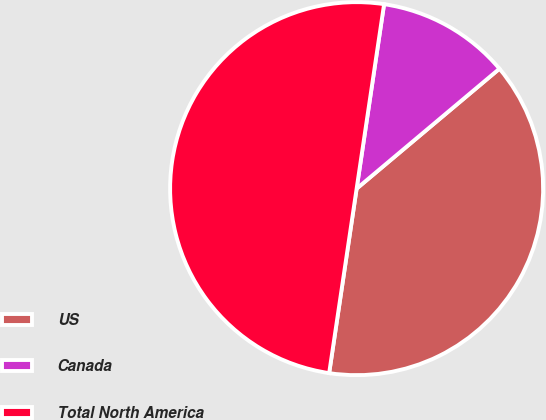Convert chart. <chart><loc_0><loc_0><loc_500><loc_500><pie_chart><fcel>US<fcel>Canada<fcel>Total North America<nl><fcel>38.47%<fcel>11.53%<fcel>50.0%<nl></chart> 